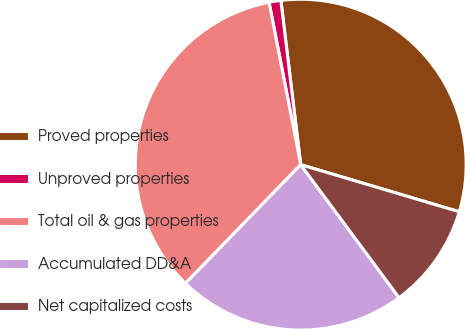Convert chart. <chart><loc_0><loc_0><loc_500><loc_500><pie_chart><fcel>Proved properties<fcel>Unproved properties<fcel>Total oil & gas properties<fcel>Accumulated DD&A<fcel>Net capitalized costs<nl><fcel>31.51%<fcel>1.15%<fcel>34.67%<fcel>22.4%<fcel>10.27%<nl></chart> 